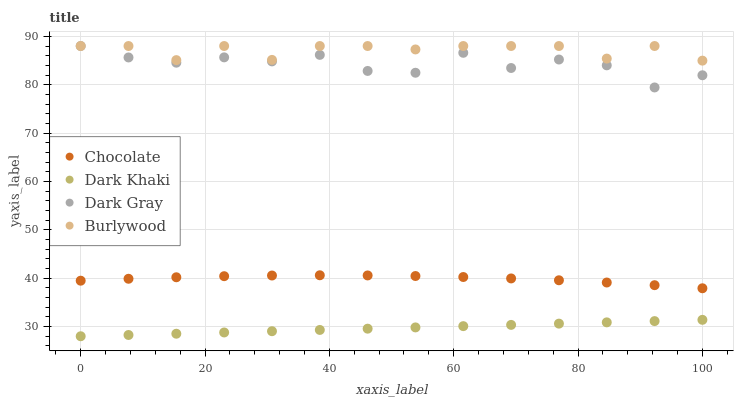Does Dark Khaki have the minimum area under the curve?
Answer yes or no. Yes. Does Burlywood have the maximum area under the curve?
Answer yes or no. Yes. Does Dark Gray have the minimum area under the curve?
Answer yes or no. No. Does Dark Gray have the maximum area under the curve?
Answer yes or no. No. Is Dark Khaki the smoothest?
Answer yes or no. Yes. Is Dark Gray the roughest?
Answer yes or no. Yes. Is Burlywood the smoothest?
Answer yes or no. No. Is Burlywood the roughest?
Answer yes or no. No. Does Dark Khaki have the lowest value?
Answer yes or no. Yes. Does Dark Gray have the lowest value?
Answer yes or no. No. Does Burlywood have the highest value?
Answer yes or no. Yes. Does Chocolate have the highest value?
Answer yes or no. No. Is Dark Khaki less than Dark Gray?
Answer yes or no. Yes. Is Burlywood greater than Chocolate?
Answer yes or no. Yes. Does Dark Gray intersect Burlywood?
Answer yes or no. Yes. Is Dark Gray less than Burlywood?
Answer yes or no. No. Is Dark Gray greater than Burlywood?
Answer yes or no. No. Does Dark Khaki intersect Dark Gray?
Answer yes or no. No. 